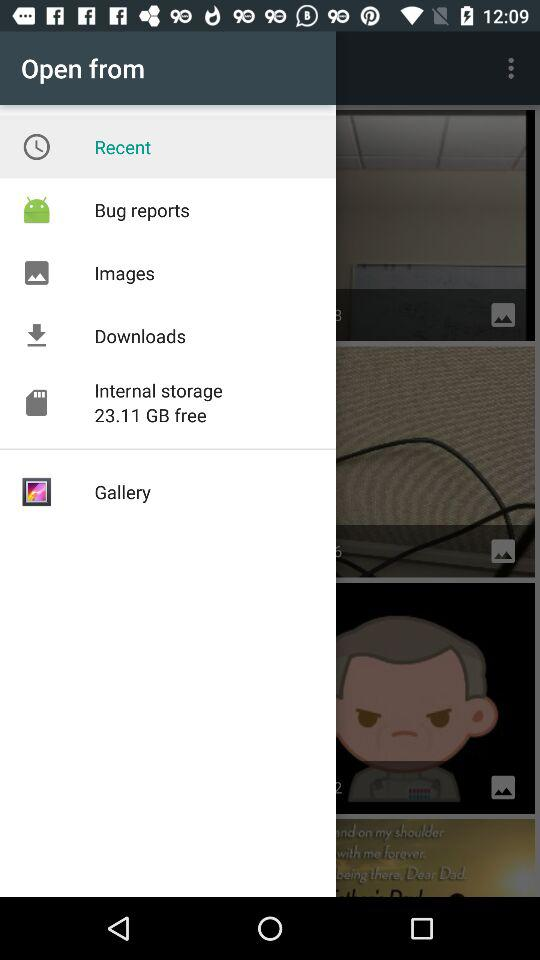How much internal storage is there? There is 23.11 GB of internal storage. 